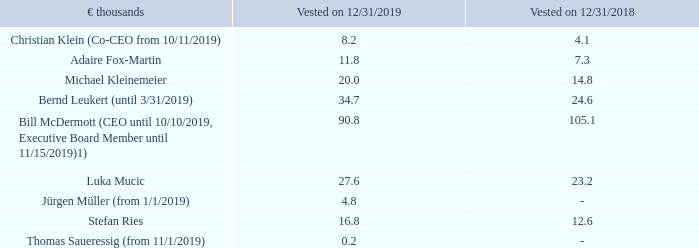The table below shows the annual pension entitlement earned during the Executive Board membership of each member of the Executive Board on reaching the scheduled retirement age of 62, based on entitlements from SAP under performance-based and salary-linked plans.
Annual Pension Entitlement
1) The rights shown here for Bill McDermott refer solely to rights under the pension plan for SAP America.
These are vested entitlements. To the extent that members continue to serve on the Executive Board and that therefore more contributions are made for them in the future, pensions actually payable at the scheduled retirement age will be higher than the amounts shown in the table.
What do the rights for Bill McDermott refer to?  Refer solely to rights under the pension plan for sap america. What kind of entitlements are annual pension entitlements as displayed in the table? Vested entitlements. In which years are the annual pension entitlements vested? 2019, 2018. In which year was the amount vested for Michael Kleinemeier larger? 20.0>14.8
Answer: 2019. What was the change in the amount for Christian Klein in 2019 from 2018?
Answer scale should be: thousand. 8.2-4.1
Answer: 4.1. What was the percentage change in the amount for Christian Klein in 2019 from 2018?
Answer scale should be: percent. (8.2-4.1)/4.1
Answer: 100. 